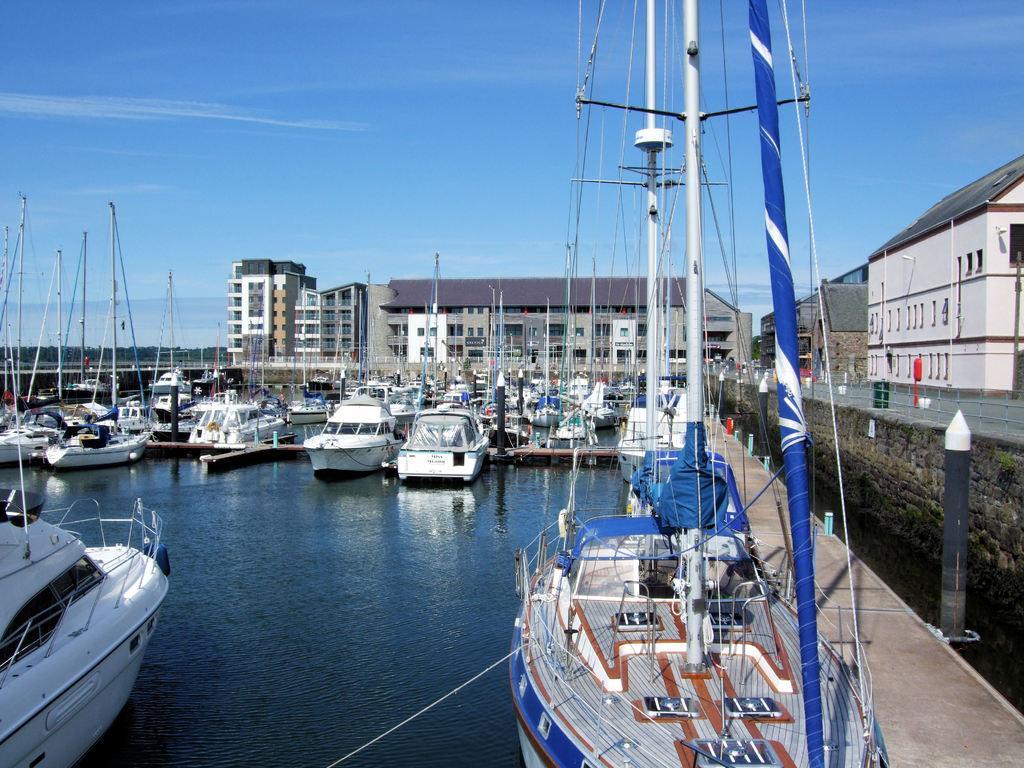How would you summarize this image in a sentence or two? In this image there are ships on the water. In the background there are buildings and on the right side there is a wall. 